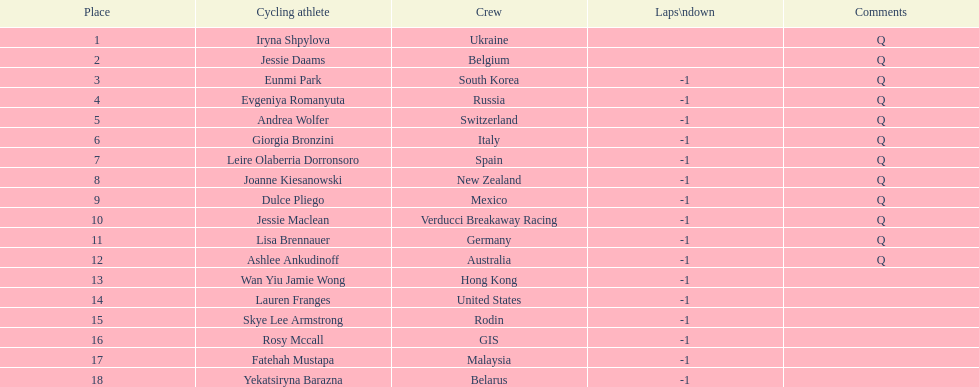Who was the top ranked competitor in this race? Iryna Shpylova. 